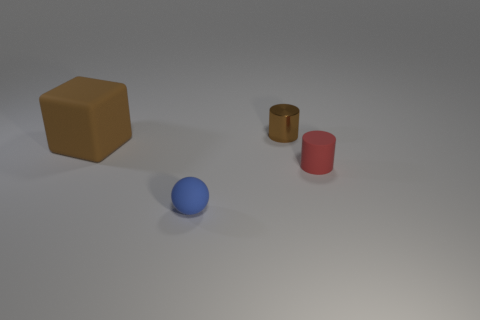There is a tiny rubber thing that is behind the small matte object to the left of the tiny red rubber thing; what is its shape?
Offer a terse response. Cylinder. Are there any brown matte cubes of the same size as the blue rubber object?
Your response must be concise. No. What number of tiny rubber objects are the same shape as the big brown matte object?
Offer a very short reply. 0. Is the number of small red objects that are left of the small matte cylinder the same as the number of small brown things that are left of the big matte cube?
Make the answer very short. Yes. Are there any big brown matte cubes?
Your answer should be compact. Yes. What size is the brown cylinder that is behind the tiny cylinder right of the tiny cylinder left of the tiny red cylinder?
Give a very brief answer. Small. What is the shape of the blue thing that is the same size as the brown metal cylinder?
Give a very brief answer. Sphere. Are there any other things that have the same material as the tiny blue object?
Your response must be concise. Yes. What number of objects are either tiny cylinders in front of the metallic object or big blue rubber things?
Keep it short and to the point. 1. Are there any tiny metal objects behind the tiny cylinder behind the small cylinder that is in front of the brown metal cylinder?
Provide a succinct answer. No. 